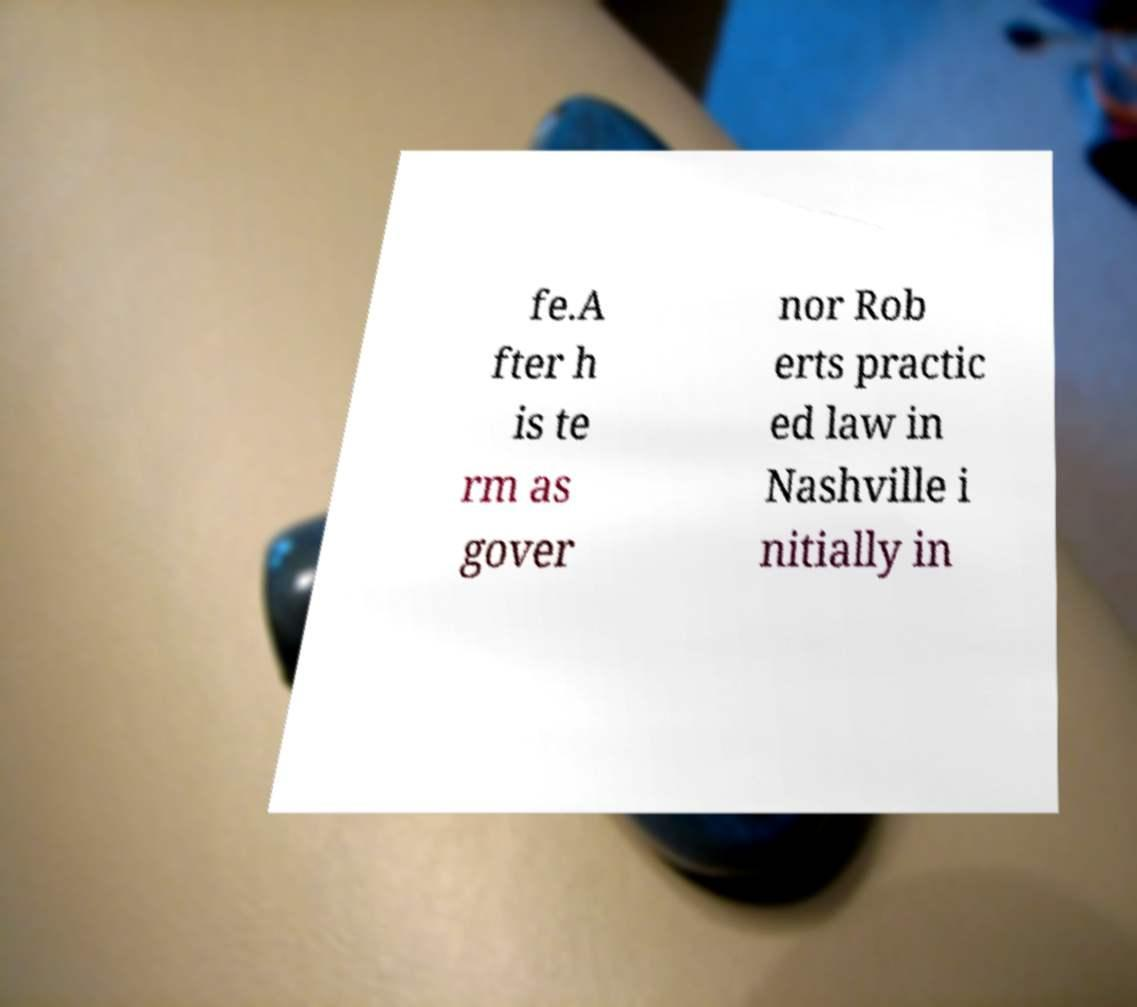I need the written content from this picture converted into text. Can you do that? fe.A fter h is te rm as gover nor Rob erts practic ed law in Nashville i nitially in 